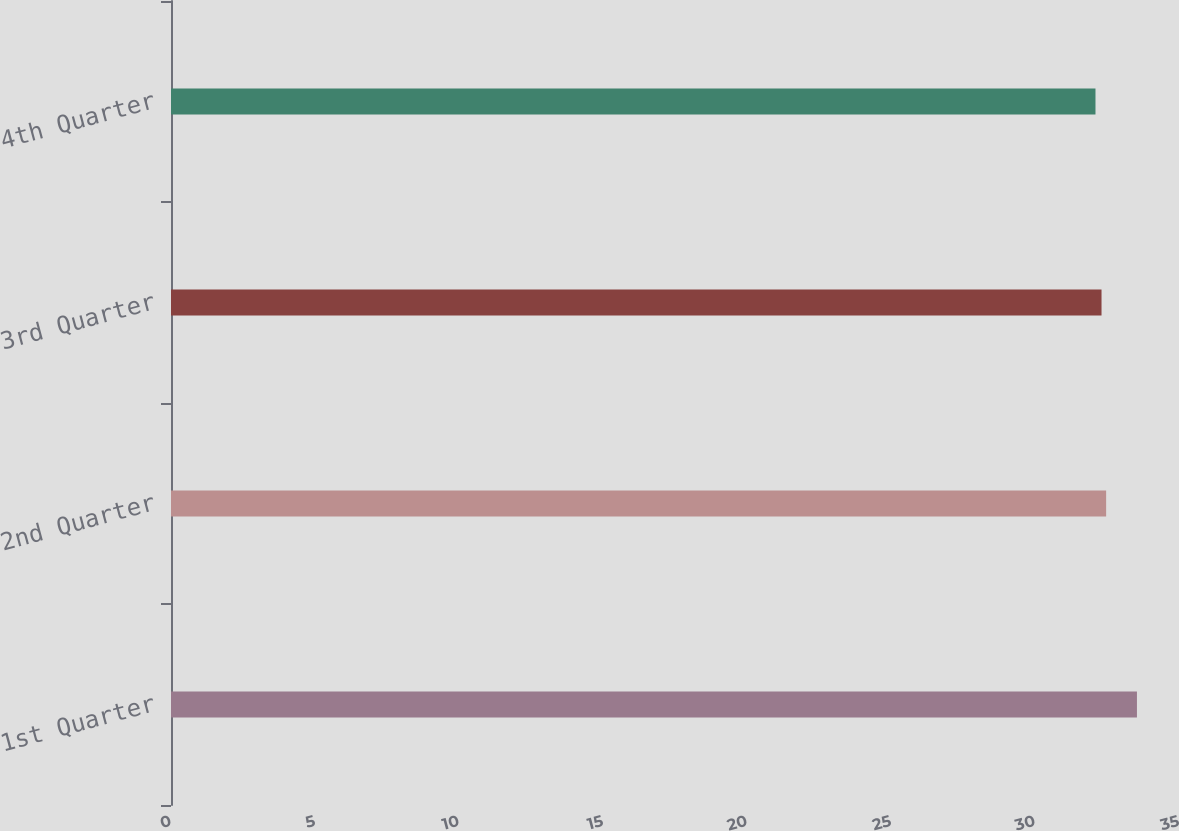Convert chart. <chart><loc_0><loc_0><loc_500><loc_500><bar_chart><fcel>1st Quarter<fcel>2nd Quarter<fcel>3rd Quarter<fcel>4th Quarter<nl><fcel>33.54<fcel>32.47<fcel>32.31<fcel>32.1<nl></chart> 